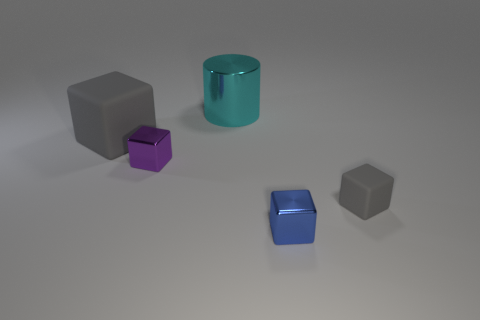Add 4 red metallic cubes. How many objects exist? 9 Subtract all cubes. How many objects are left? 1 Subtract 0 yellow balls. How many objects are left? 5 Subtract all large gray things. Subtract all small metal objects. How many objects are left? 2 Add 1 purple metal cubes. How many purple metal cubes are left? 2 Add 1 tiny purple objects. How many tiny purple objects exist? 2 